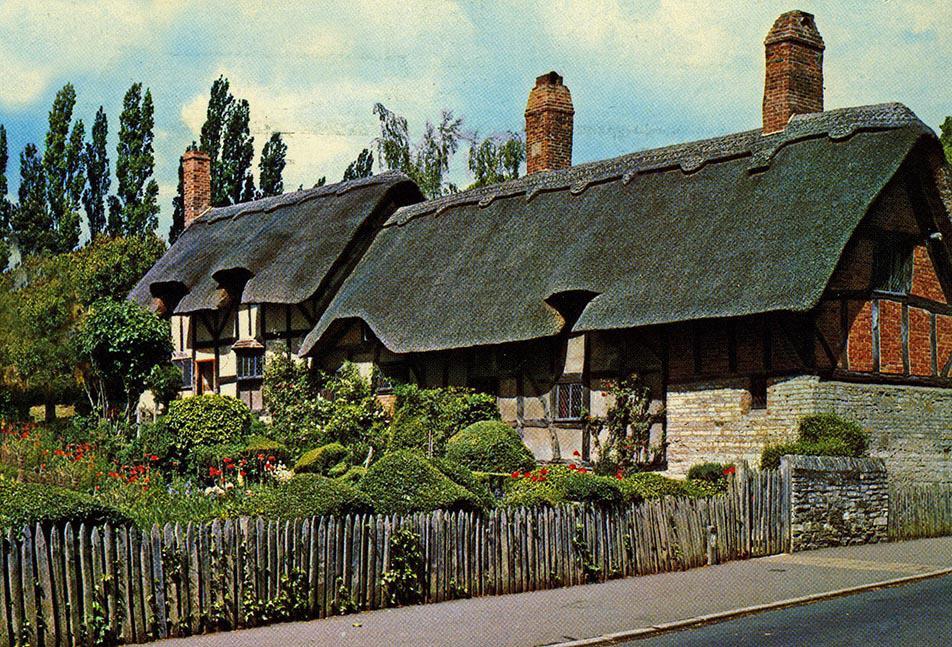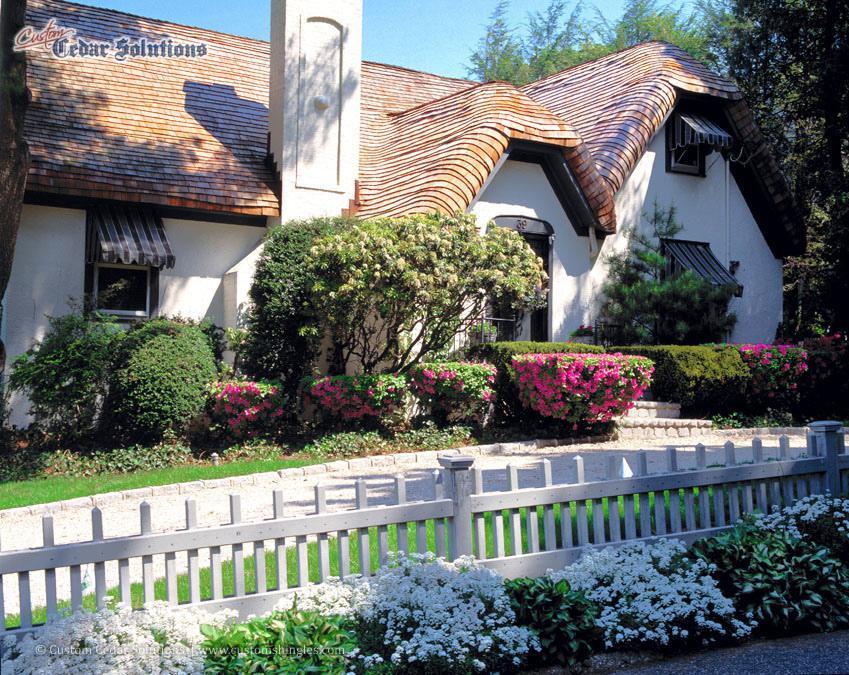The first image is the image on the left, the second image is the image on the right. Examine the images to the left and right. Is the description "The thatching on the house in the image to the right, is a dark gray." accurate? Answer yes or no. No. 